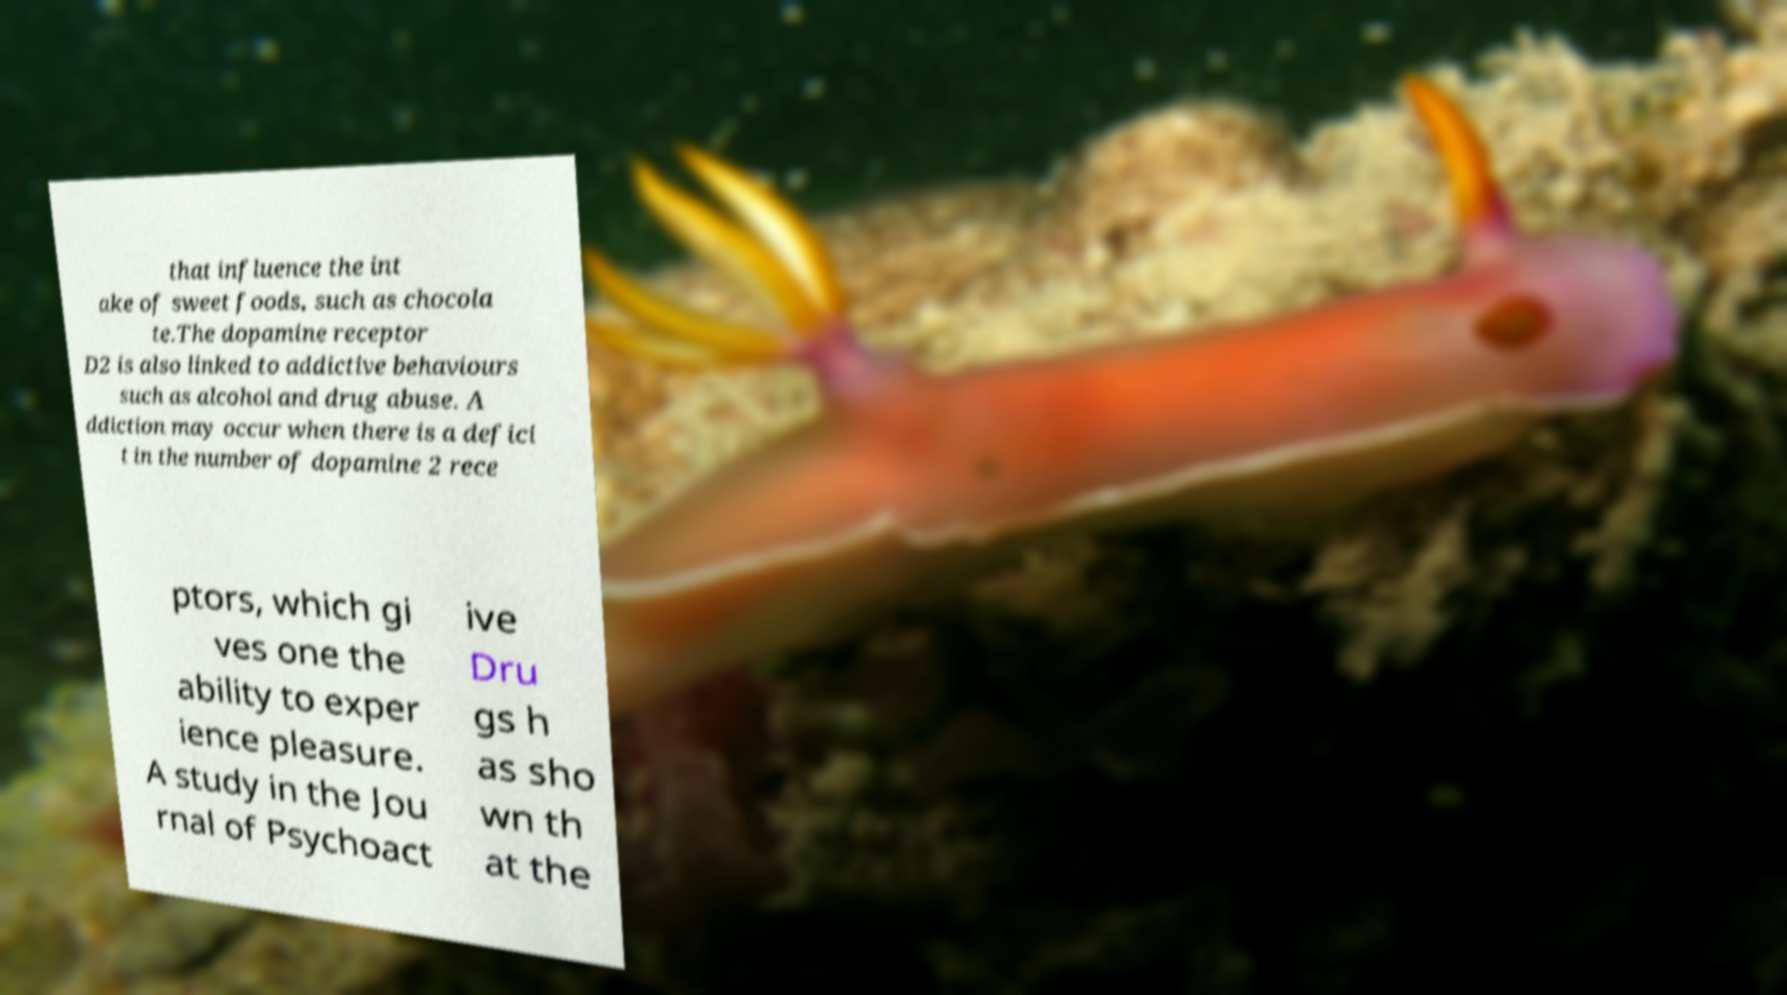For documentation purposes, I need the text within this image transcribed. Could you provide that? that influence the int ake of sweet foods, such as chocola te.The dopamine receptor D2 is also linked to addictive behaviours such as alcohol and drug abuse. A ddiction may occur when there is a defici t in the number of dopamine 2 rece ptors, which gi ves one the ability to exper ience pleasure. A study in the Jou rnal of Psychoact ive Dru gs h as sho wn th at the 